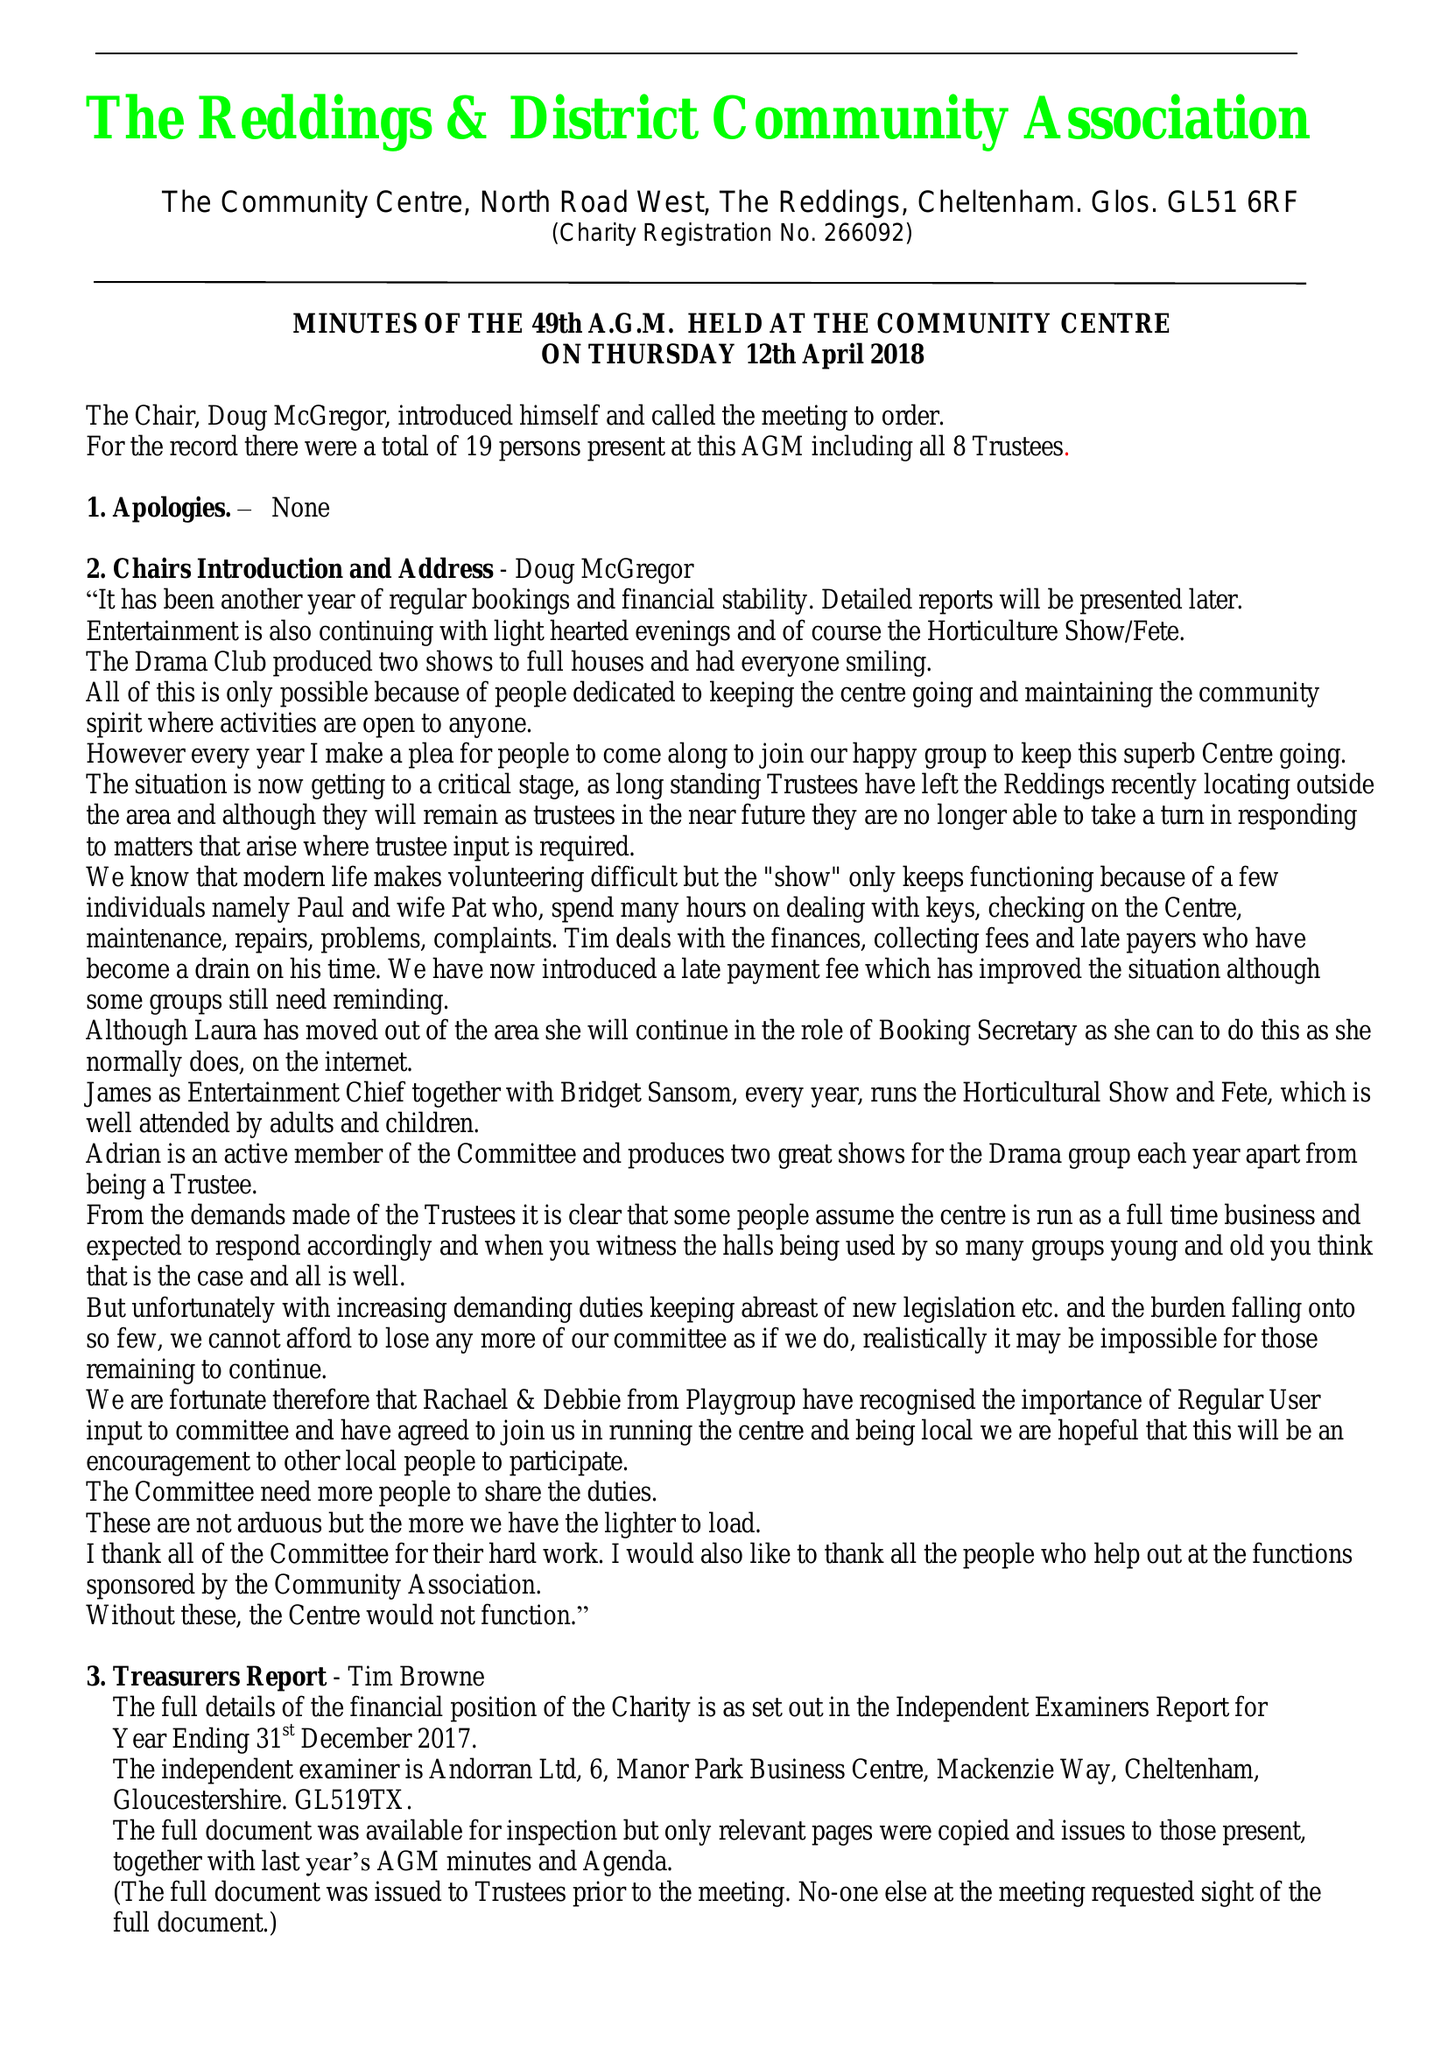What is the value for the income_annually_in_british_pounds?
Answer the question using a single word or phrase. 36136.00 